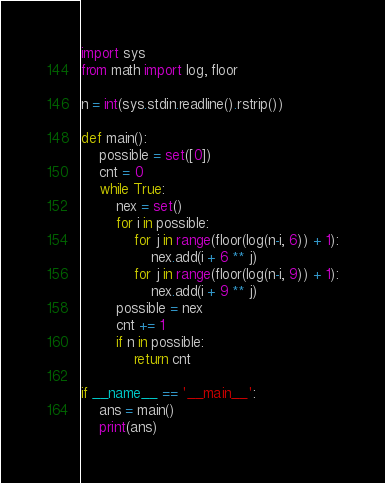<code> <loc_0><loc_0><loc_500><loc_500><_Python_>import sys
from math import log, floor

n = int(sys.stdin.readline().rstrip())

def main():
    possible = set([0])
    cnt = 0
    while True:
        nex = set()
        for i in possible:
            for j in range(floor(log(n-i, 6)) + 1):
                nex.add(i + 6 ** j)
            for j in range(floor(log(n-i, 9)) + 1):
                nex.add(i + 9 ** j)
        possible = nex
        cnt += 1
        if n in possible:
            return cnt

if __name__ == '__main__':
    ans = main()
    print(ans)</code> 